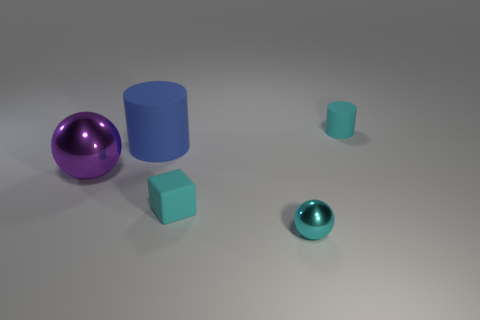Is the color of the tiny rubber block the same as the tiny shiny sphere? Yes, both the tiny rubber block and the tiny shiny sphere share the same hue of cyan, although the difference in material properties might make their colors appear slightly different under light. The sphere, being shiny, reflects light more and can look brighter, while the rubber block has a matte finish that diffuses light, giving a less reflective appearance. 